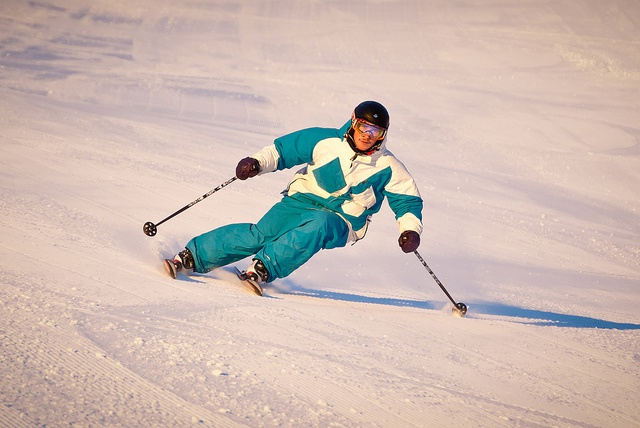Describe the objects in this image and their specific colors. I can see people in gray, teal, beige, and tan tones and skis in gray, tan, and maroon tones in this image. 